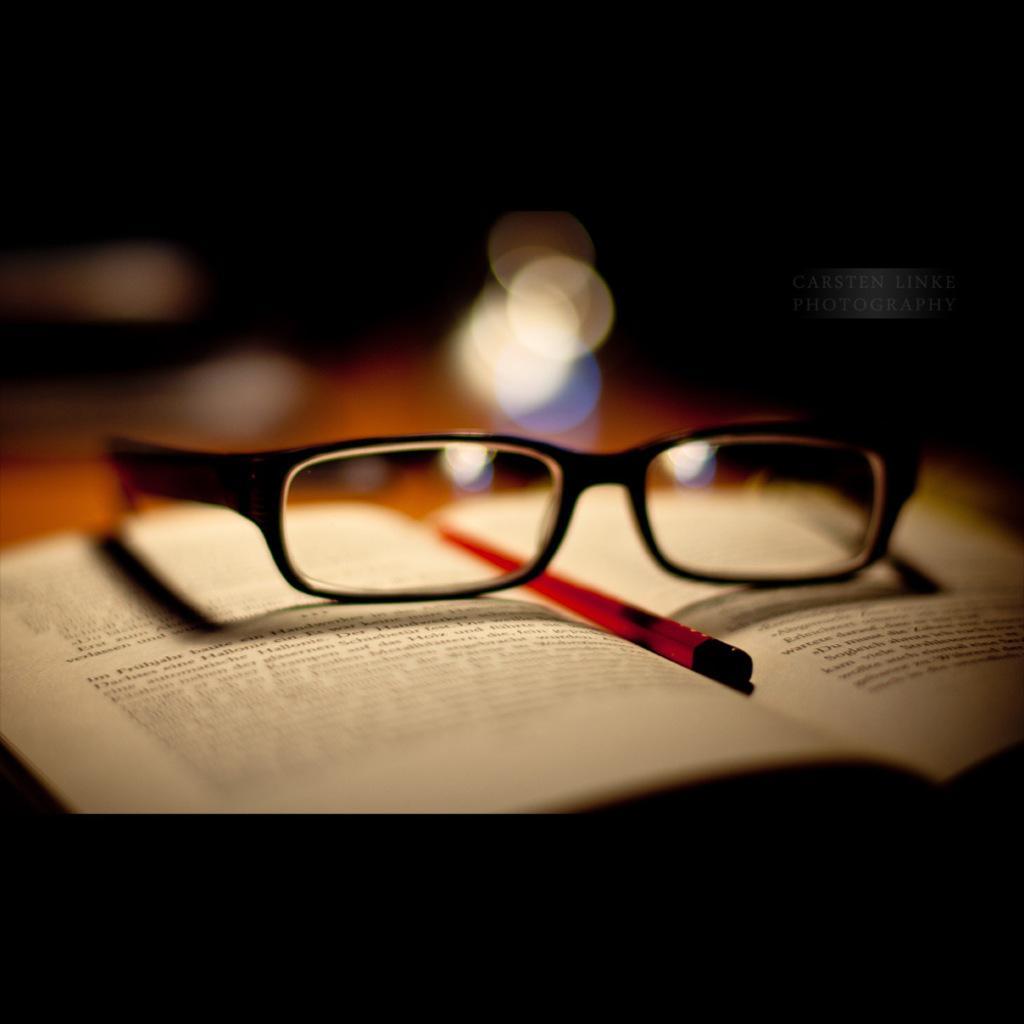How would you summarize this image in a sentence or two? In this picture we can see a pen and spectacles on the book, in the background we can see few lights. 